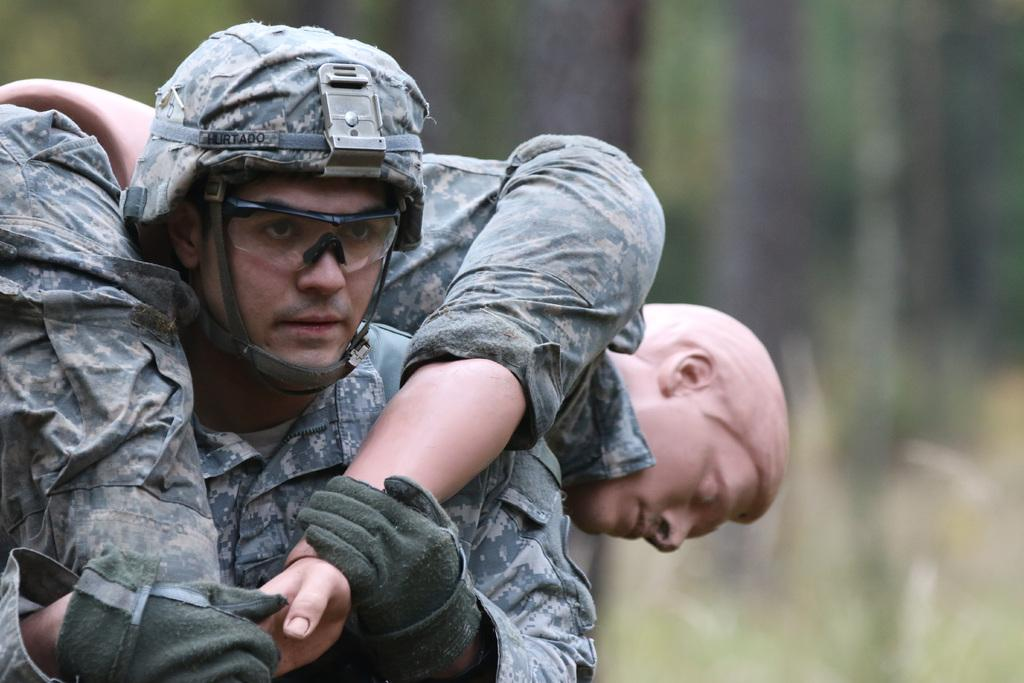How many people are in the image? There are two people in the image. What protective gear is one of the people wearing? One person is wearing goggles. What other protective gear is the other person wearing? The other person is wearing gloves. Can you describe the background of the image? The background of the image is blurry. What type of jam is being spread on the pigs in the image? There are no pigs or jam present in the image. Can you describe how the people are touching the pigs in the image? There are no pigs or touching of pigs depicted in the image. 